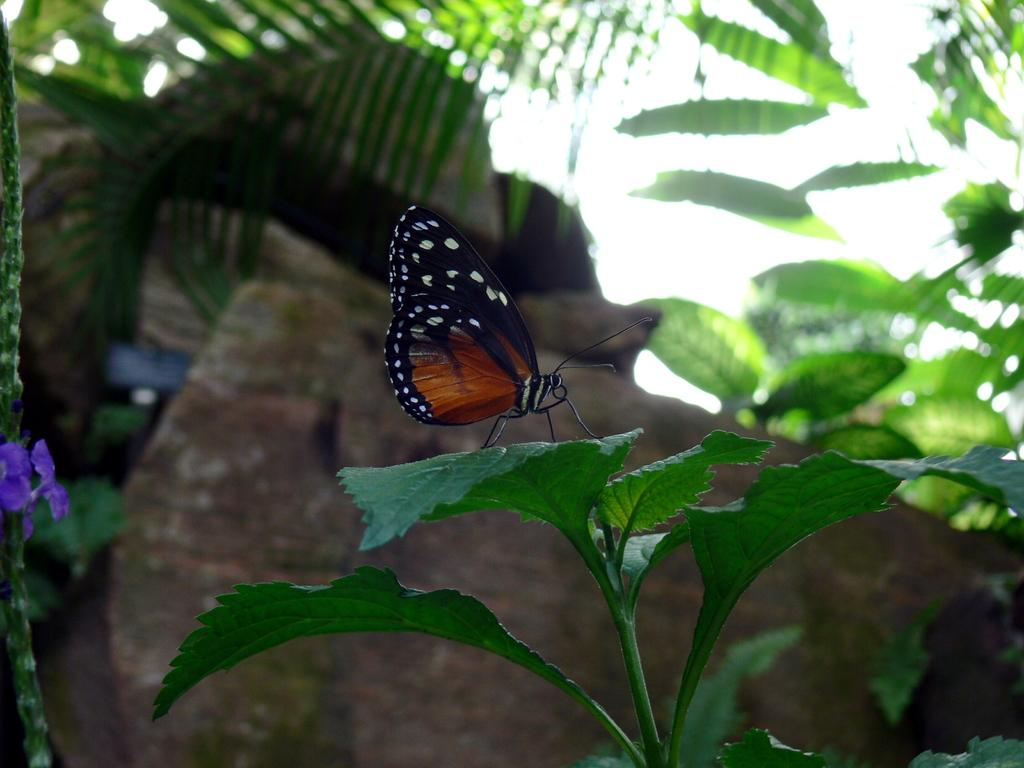What is on the plant in the image? There is a butterfly on a plant in the image. What can be seen in the background of the image? There are rocks and leaves in the background of the image. What activity is the giraffe participating in with the butterfly in the image? There is no giraffe present in the image, so it cannot be participating in any activity with the butterfly. 